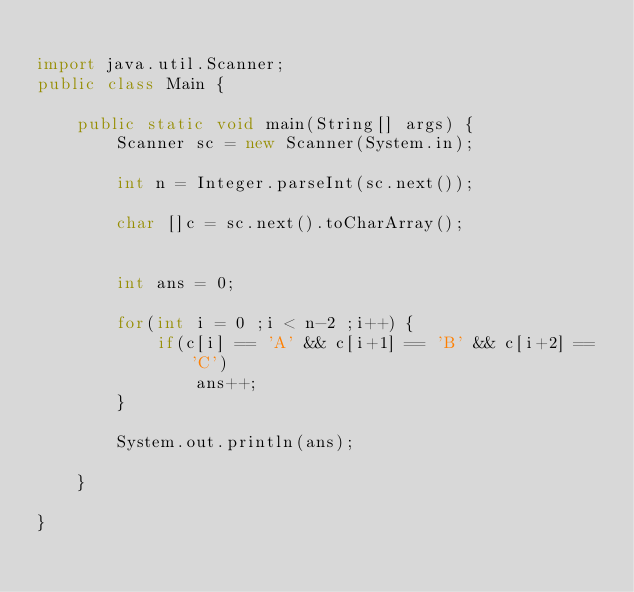<code> <loc_0><loc_0><loc_500><loc_500><_Java_>
import java.util.Scanner;
public class Main {

	public static void main(String[] args) {
		Scanner sc = new Scanner(System.in);
		
		int n = Integer.parseInt(sc.next());
		
		char []c = sc.next().toCharArray();
		
		
		int ans = 0;
		
		for(int i = 0 ;i < n-2 ;i++) {
			if(c[i] == 'A' && c[i+1] == 'B' && c[i+2] == 'C') 
				ans++;
		}
		
		System.out.println(ans);

	}

}
</code> 